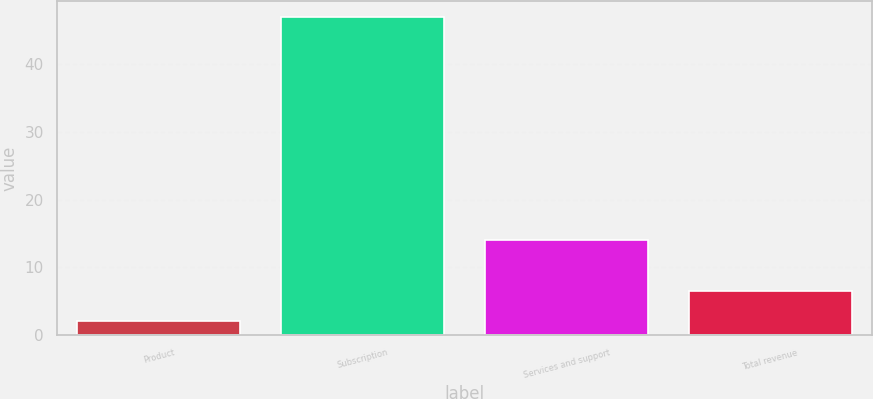<chart> <loc_0><loc_0><loc_500><loc_500><bar_chart><fcel>Product<fcel>Subscription<fcel>Services and support<fcel>Total revenue<nl><fcel>2<fcel>47<fcel>14<fcel>6.5<nl></chart> 